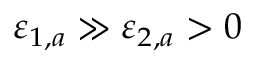<formula> <loc_0><loc_0><loc_500><loc_500>\varepsilon _ { 1 , a } \gg \varepsilon _ { 2 , a } > 0</formula> 